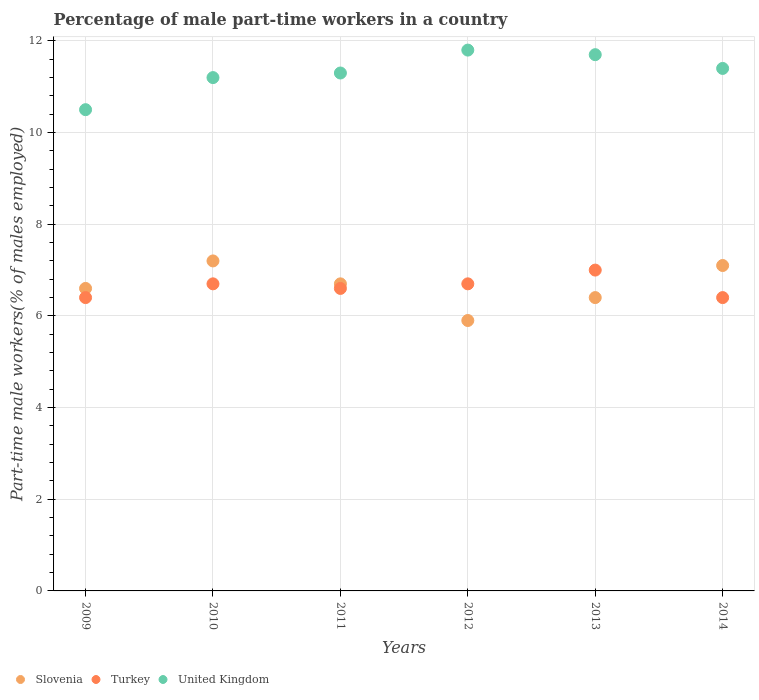How many different coloured dotlines are there?
Provide a succinct answer. 3. What is the percentage of male part-time workers in United Kingdom in 2014?
Ensure brevity in your answer.  11.4. Across all years, what is the minimum percentage of male part-time workers in United Kingdom?
Provide a short and direct response. 10.5. What is the total percentage of male part-time workers in Slovenia in the graph?
Your response must be concise. 39.9. What is the difference between the percentage of male part-time workers in Slovenia in 2009 and that in 2010?
Offer a very short reply. -0.6. What is the difference between the percentage of male part-time workers in United Kingdom in 2014 and the percentage of male part-time workers in Turkey in 2012?
Keep it short and to the point. 4.7. What is the average percentage of male part-time workers in United Kingdom per year?
Offer a very short reply. 11.32. In the year 2010, what is the difference between the percentage of male part-time workers in United Kingdom and percentage of male part-time workers in Slovenia?
Offer a very short reply. 4. What is the ratio of the percentage of male part-time workers in United Kingdom in 2009 to that in 2011?
Your answer should be very brief. 0.93. What is the difference between the highest and the second highest percentage of male part-time workers in Turkey?
Your response must be concise. 0.3. What is the difference between the highest and the lowest percentage of male part-time workers in Turkey?
Offer a very short reply. 0.6. Is the sum of the percentage of male part-time workers in Slovenia in 2009 and 2011 greater than the maximum percentage of male part-time workers in United Kingdom across all years?
Provide a short and direct response. Yes. Is it the case that in every year, the sum of the percentage of male part-time workers in United Kingdom and percentage of male part-time workers in Turkey  is greater than the percentage of male part-time workers in Slovenia?
Give a very brief answer. Yes. Is the percentage of male part-time workers in Turkey strictly greater than the percentage of male part-time workers in Slovenia over the years?
Provide a short and direct response. No. How many dotlines are there?
Your response must be concise. 3. What is the title of the graph?
Offer a very short reply. Percentage of male part-time workers in a country. What is the label or title of the X-axis?
Provide a succinct answer. Years. What is the label or title of the Y-axis?
Provide a succinct answer. Part-time male workers(% of males employed). What is the Part-time male workers(% of males employed) in Slovenia in 2009?
Offer a terse response. 6.6. What is the Part-time male workers(% of males employed) in Turkey in 2009?
Your response must be concise. 6.4. What is the Part-time male workers(% of males employed) in United Kingdom in 2009?
Keep it short and to the point. 10.5. What is the Part-time male workers(% of males employed) of Slovenia in 2010?
Your response must be concise. 7.2. What is the Part-time male workers(% of males employed) of Turkey in 2010?
Keep it short and to the point. 6.7. What is the Part-time male workers(% of males employed) in United Kingdom in 2010?
Offer a very short reply. 11.2. What is the Part-time male workers(% of males employed) in Slovenia in 2011?
Make the answer very short. 6.7. What is the Part-time male workers(% of males employed) of Turkey in 2011?
Give a very brief answer. 6.6. What is the Part-time male workers(% of males employed) of United Kingdom in 2011?
Make the answer very short. 11.3. What is the Part-time male workers(% of males employed) of Slovenia in 2012?
Provide a succinct answer. 5.9. What is the Part-time male workers(% of males employed) in Turkey in 2012?
Give a very brief answer. 6.7. What is the Part-time male workers(% of males employed) of United Kingdom in 2012?
Give a very brief answer. 11.8. What is the Part-time male workers(% of males employed) of Slovenia in 2013?
Provide a short and direct response. 6.4. What is the Part-time male workers(% of males employed) of United Kingdom in 2013?
Offer a terse response. 11.7. What is the Part-time male workers(% of males employed) of Slovenia in 2014?
Make the answer very short. 7.1. What is the Part-time male workers(% of males employed) of Turkey in 2014?
Keep it short and to the point. 6.4. What is the Part-time male workers(% of males employed) in United Kingdom in 2014?
Make the answer very short. 11.4. Across all years, what is the maximum Part-time male workers(% of males employed) of Slovenia?
Keep it short and to the point. 7.2. Across all years, what is the maximum Part-time male workers(% of males employed) in Turkey?
Your answer should be very brief. 7. Across all years, what is the maximum Part-time male workers(% of males employed) of United Kingdom?
Offer a terse response. 11.8. Across all years, what is the minimum Part-time male workers(% of males employed) in Slovenia?
Provide a short and direct response. 5.9. Across all years, what is the minimum Part-time male workers(% of males employed) of Turkey?
Your answer should be very brief. 6.4. What is the total Part-time male workers(% of males employed) in Slovenia in the graph?
Your response must be concise. 39.9. What is the total Part-time male workers(% of males employed) of Turkey in the graph?
Offer a terse response. 39.8. What is the total Part-time male workers(% of males employed) in United Kingdom in the graph?
Provide a succinct answer. 67.9. What is the difference between the Part-time male workers(% of males employed) of Turkey in 2009 and that in 2010?
Your answer should be compact. -0.3. What is the difference between the Part-time male workers(% of males employed) in Slovenia in 2009 and that in 2011?
Your response must be concise. -0.1. What is the difference between the Part-time male workers(% of males employed) in United Kingdom in 2009 and that in 2012?
Offer a very short reply. -1.3. What is the difference between the Part-time male workers(% of males employed) in Turkey in 2009 and that in 2013?
Make the answer very short. -0.6. What is the difference between the Part-time male workers(% of males employed) in United Kingdom in 2009 and that in 2013?
Ensure brevity in your answer.  -1.2. What is the difference between the Part-time male workers(% of males employed) in United Kingdom in 2009 and that in 2014?
Your response must be concise. -0.9. What is the difference between the Part-time male workers(% of males employed) of United Kingdom in 2010 and that in 2011?
Your answer should be compact. -0.1. What is the difference between the Part-time male workers(% of males employed) in Turkey in 2010 and that in 2012?
Provide a short and direct response. 0. What is the difference between the Part-time male workers(% of males employed) in Turkey in 2010 and that in 2013?
Make the answer very short. -0.3. What is the difference between the Part-time male workers(% of males employed) in United Kingdom in 2010 and that in 2013?
Give a very brief answer. -0.5. What is the difference between the Part-time male workers(% of males employed) in Slovenia in 2010 and that in 2014?
Provide a succinct answer. 0.1. What is the difference between the Part-time male workers(% of males employed) of Slovenia in 2011 and that in 2012?
Ensure brevity in your answer.  0.8. What is the difference between the Part-time male workers(% of males employed) in Turkey in 2011 and that in 2012?
Your answer should be compact. -0.1. What is the difference between the Part-time male workers(% of males employed) in Slovenia in 2011 and that in 2013?
Your response must be concise. 0.3. What is the difference between the Part-time male workers(% of males employed) in Turkey in 2011 and that in 2013?
Your response must be concise. -0.4. What is the difference between the Part-time male workers(% of males employed) of Slovenia in 2012 and that in 2013?
Provide a short and direct response. -0.5. What is the difference between the Part-time male workers(% of males employed) of Slovenia in 2012 and that in 2014?
Offer a terse response. -1.2. What is the difference between the Part-time male workers(% of males employed) of Turkey in 2012 and that in 2014?
Your answer should be compact. 0.3. What is the difference between the Part-time male workers(% of males employed) in United Kingdom in 2012 and that in 2014?
Offer a very short reply. 0.4. What is the difference between the Part-time male workers(% of males employed) in Slovenia in 2009 and the Part-time male workers(% of males employed) in Turkey in 2010?
Provide a short and direct response. -0.1. What is the difference between the Part-time male workers(% of males employed) of Slovenia in 2009 and the Part-time male workers(% of males employed) of United Kingdom in 2010?
Make the answer very short. -4.6. What is the difference between the Part-time male workers(% of males employed) of Turkey in 2009 and the Part-time male workers(% of males employed) of United Kingdom in 2010?
Your answer should be very brief. -4.8. What is the difference between the Part-time male workers(% of males employed) of Slovenia in 2009 and the Part-time male workers(% of males employed) of Turkey in 2011?
Offer a terse response. 0. What is the difference between the Part-time male workers(% of males employed) in Slovenia in 2009 and the Part-time male workers(% of males employed) in United Kingdom in 2011?
Keep it short and to the point. -4.7. What is the difference between the Part-time male workers(% of males employed) of Turkey in 2009 and the Part-time male workers(% of males employed) of United Kingdom in 2011?
Give a very brief answer. -4.9. What is the difference between the Part-time male workers(% of males employed) in Slovenia in 2009 and the Part-time male workers(% of males employed) in Turkey in 2012?
Keep it short and to the point. -0.1. What is the difference between the Part-time male workers(% of males employed) of Slovenia in 2009 and the Part-time male workers(% of males employed) of United Kingdom in 2012?
Offer a very short reply. -5.2. What is the difference between the Part-time male workers(% of males employed) in Turkey in 2009 and the Part-time male workers(% of males employed) in United Kingdom in 2012?
Offer a terse response. -5.4. What is the difference between the Part-time male workers(% of males employed) of Slovenia in 2009 and the Part-time male workers(% of males employed) of United Kingdom in 2013?
Your answer should be compact. -5.1. What is the difference between the Part-time male workers(% of males employed) of Turkey in 2009 and the Part-time male workers(% of males employed) of United Kingdom in 2013?
Your response must be concise. -5.3. What is the difference between the Part-time male workers(% of males employed) in Slovenia in 2009 and the Part-time male workers(% of males employed) in United Kingdom in 2014?
Your answer should be compact. -4.8. What is the difference between the Part-time male workers(% of males employed) in Turkey in 2009 and the Part-time male workers(% of males employed) in United Kingdom in 2014?
Make the answer very short. -5. What is the difference between the Part-time male workers(% of males employed) in Slovenia in 2010 and the Part-time male workers(% of males employed) in United Kingdom in 2011?
Your response must be concise. -4.1. What is the difference between the Part-time male workers(% of males employed) of Slovenia in 2010 and the Part-time male workers(% of males employed) of Turkey in 2012?
Make the answer very short. 0.5. What is the difference between the Part-time male workers(% of males employed) in Slovenia in 2010 and the Part-time male workers(% of males employed) in Turkey in 2013?
Offer a terse response. 0.2. What is the difference between the Part-time male workers(% of males employed) of Slovenia in 2010 and the Part-time male workers(% of males employed) of United Kingdom in 2013?
Your answer should be very brief. -4.5. What is the difference between the Part-time male workers(% of males employed) in Turkey in 2010 and the Part-time male workers(% of males employed) in United Kingdom in 2013?
Provide a short and direct response. -5. What is the difference between the Part-time male workers(% of males employed) in Slovenia in 2010 and the Part-time male workers(% of males employed) in United Kingdom in 2014?
Give a very brief answer. -4.2. What is the difference between the Part-time male workers(% of males employed) in Turkey in 2010 and the Part-time male workers(% of males employed) in United Kingdom in 2014?
Your answer should be compact. -4.7. What is the difference between the Part-time male workers(% of males employed) in Slovenia in 2011 and the Part-time male workers(% of males employed) in United Kingdom in 2013?
Offer a very short reply. -5. What is the difference between the Part-time male workers(% of males employed) of Slovenia in 2011 and the Part-time male workers(% of males employed) of Turkey in 2014?
Offer a very short reply. 0.3. What is the difference between the Part-time male workers(% of males employed) in Slovenia in 2012 and the Part-time male workers(% of males employed) in United Kingdom in 2014?
Offer a very short reply. -5.5. What is the difference between the Part-time male workers(% of males employed) of Turkey in 2012 and the Part-time male workers(% of males employed) of United Kingdom in 2014?
Give a very brief answer. -4.7. What is the difference between the Part-time male workers(% of males employed) in Slovenia in 2013 and the Part-time male workers(% of males employed) in Turkey in 2014?
Your response must be concise. 0. What is the difference between the Part-time male workers(% of males employed) of Slovenia in 2013 and the Part-time male workers(% of males employed) of United Kingdom in 2014?
Make the answer very short. -5. What is the average Part-time male workers(% of males employed) of Slovenia per year?
Provide a succinct answer. 6.65. What is the average Part-time male workers(% of males employed) of Turkey per year?
Your answer should be very brief. 6.63. What is the average Part-time male workers(% of males employed) in United Kingdom per year?
Provide a succinct answer. 11.32. In the year 2010, what is the difference between the Part-time male workers(% of males employed) of Slovenia and Part-time male workers(% of males employed) of Turkey?
Provide a short and direct response. 0.5. In the year 2010, what is the difference between the Part-time male workers(% of males employed) in Slovenia and Part-time male workers(% of males employed) in United Kingdom?
Offer a terse response. -4. In the year 2010, what is the difference between the Part-time male workers(% of males employed) in Turkey and Part-time male workers(% of males employed) in United Kingdom?
Ensure brevity in your answer.  -4.5. In the year 2011, what is the difference between the Part-time male workers(% of males employed) in Slovenia and Part-time male workers(% of males employed) in Turkey?
Make the answer very short. 0.1. In the year 2011, what is the difference between the Part-time male workers(% of males employed) in Slovenia and Part-time male workers(% of males employed) in United Kingdom?
Give a very brief answer. -4.6. In the year 2011, what is the difference between the Part-time male workers(% of males employed) in Turkey and Part-time male workers(% of males employed) in United Kingdom?
Give a very brief answer. -4.7. In the year 2012, what is the difference between the Part-time male workers(% of males employed) of Slovenia and Part-time male workers(% of males employed) of United Kingdom?
Keep it short and to the point. -5.9. In the year 2013, what is the difference between the Part-time male workers(% of males employed) of Turkey and Part-time male workers(% of males employed) of United Kingdom?
Your answer should be very brief. -4.7. In the year 2014, what is the difference between the Part-time male workers(% of males employed) in Slovenia and Part-time male workers(% of males employed) in Turkey?
Offer a very short reply. 0.7. In the year 2014, what is the difference between the Part-time male workers(% of males employed) of Slovenia and Part-time male workers(% of males employed) of United Kingdom?
Provide a short and direct response. -4.3. In the year 2014, what is the difference between the Part-time male workers(% of males employed) of Turkey and Part-time male workers(% of males employed) of United Kingdom?
Provide a short and direct response. -5. What is the ratio of the Part-time male workers(% of males employed) in Turkey in 2009 to that in 2010?
Make the answer very short. 0.96. What is the ratio of the Part-time male workers(% of males employed) in United Kingdom in 2009 to that in 2010?
Offer a very short reply. 0.94. What is the ratio of the Part-time male workers(% of males employed) of Slovenia in 2009 to that in 2011?
Your answer should be very brief. 0.99. What is the ratio of the Part-time male workers(% of males employed) in Turkey in 2009 to that in 2011?
Offer a terse response. 0.97. What is the ratio of the Part-time male workers(% of males employed) in United Kingdom in 2009 to that in 2011?
Offer a very short reply. 0.93. What is the ratio of the Part-time male workers(% of males employed) of Slovenia in 2009 to that in 2012?
Keep it short and to the point. 1.12. What is the ratio of the Part-time male workers(% of males employed) of Turkey in 2009 to that in 2012?
Offer a very short reply. 0.96. What is the ratio of the Part-time male workers(% of males employed) of United Kingdom in 2009 to that in 2012?
Give a very brief answer. 0.89. What is the ratio of the Part-time male workers(% of males employed) of Slovenia in 2009 to that in 2013?
Your response must be concise. 1.03. What is the ratio of the Part-time male workers(% of males employed) in Turkey in 2009 to that in 2013?
Provide a short and direct response. 0.91. What is the ratio of the Part-time male workers(% of males employed) in United Kingdom in 2009 to that in 2013?
Your response must be concise. 0.9. What is the ratio of the Part-time male workers(% of males employed) in Slovenia in 2009 to that in 2014?
Offer a very short reply. 0.93. What is the ratio of the Part-time male workers(% of males employed) of United Kingdom in 2009 to that in 2014?
Give a very brief answer. 0.92. What is the ratio of the Part-time male workers(% of males employed) in Slovenia in 2010 to that in 2011?
Your response must be concise. 1.07. What is the ratio of the Part-time male workers(% of males employed) of Turkey in 2010 to that in 2011?
Give a very brief answer. 1.02. What is the ratio of the Part-time male workers(% of males employed) of United Kingdom in 2010 to that in 2011?
Your response must be concise. 0.99. What is the ratio of the Part-time male workers(% of males employed) in Slovenia in 2010 to that in 2012?
Offer a terse response. 1.22. What is the ratio of the Part-time male workers(% of males employed) in United Kingdom in 2010 to that in 2012?
Keep it short and to the point. 0.95. What is the ratio of the Part-time male workers(% of males employed) of Slovenia in 2010 to that in 2013?
Provide a short and direct response. 1.12. What is the ratio of the Part-time male workers(% of males employed) of Turkey in 2010 to that in 2013?
Provide a short and direct response. 0.96. What is the ratio of the Part-time male workers(% of males employed) of United Kingdom in 2010 to that in 2013?
Keep it short and to the point. 0.96. What is the ratio of the Part-time male workers(% of males employed) in Slovenia in 2010 to that in 2014?
Keep it short and to the point. 1.01. What is the ratio of the Part-time male workers(% of males employed) in Turkey in 2010 to that in 2014?
Make the answer very short. 1.05. What is the ratio of the Part-time male workers(% of males employed) in United Kingdom in 2010 to that in 2014?
Your answer should be very brief. 0.98. What is the ratio of the Part-time male workers(% of males employed) of Slovenia in 2011 to that in 2012?
Offer a terse response. 1.14. What is the ratio of the Part-time male workers(% of males employed) in Turkey in 2011 to that in 2012?
Offer a very short reply. 0.99. What is the ratio of the Part-time male workers(% of males employed) of United Kingdom in 2011 to that in 2012?
Offer a very short reply. 0.96. What is the ratio of the Part-time male workers(% of males employed) of Slovenia in 2011 to that in 2013?
Your response must be concise. 1.05. What is the ratio of the Part-time male workers(% of males employed) of Turkey in 2011 to that in 2013?
Your answer should be very brief. 0.94. What is the ratio of the Part-time male workers(% of males employed) in United Kingdom in 2011 to that in 2013?
Keep it short and to the point. 0.97. What is the ratio of the Part-time male workers(% of males employed) in Slovenia in 2011 to that in 2014?
Ensure brevity in your answer.  0.94. What is the ratio of the Part-time male workers(% of males employed) in Turkey in 2011 to that in 2014?
Provide a succinct answer. 1.03. What is the ratio of the Part-time male workers(% of males employed) of Slovenia in 2012 to that in 2013?
Make the answer very short. 0.92. What is the ratio of the Part-time male workers(% of males employed) of Turkey in 2012 to that in 2013?
Ensure brevity in your answer.  0.96. What is the ratio of the Part-time male workers(% of males employed) in United Kingdom in 2012 to that in 2013?
Ensure brevity in your answer.  1.01. What is the ratio of the Part-time male workers(% of males employed) of Slovenia in 2012 to that in 2014?
Offer a terse response. 0.83. What is the ratio of the Part-time male workers(% of males employed) of Turkey in 2012 to that in 2014?
Your response must be concise. 1.05. What is the ratio of the Part-time male workers(% of males employed) of United Kingdom in 2012 to that in 2014?
Offer a terse response. 1.04. What is the ratio of the Part-time male workers(% of males employed) of Slovenia in 2013 to that in 2014?
Keep it short and to the point. 0.9. What is the ratio of the Part-time male workers(% of males employed) in Turkey in 2013 to that in 2014?
Make the answer very short. 1.09. What is the ratio of the Part-time male workers(% of males employed) in United Kingdom in 2013 to that in 2014?
Ensure brevity in your answer.  1.03. What is the difference between the highest and the second highest Part-time male workers(% of males employed) of Slovenia?
Your answer should be very brief. 0.1. 